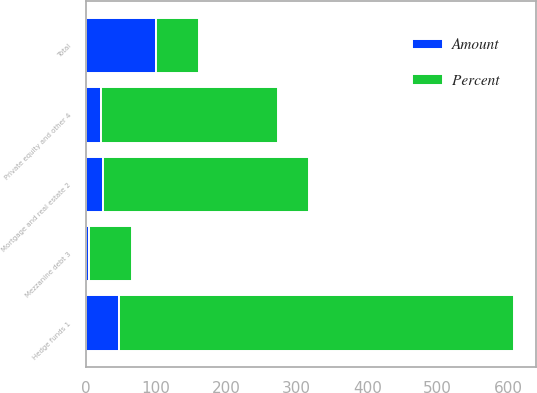<chart> <loc_0><loc_0><loc_500><loc_500><stacked_bar_chart><ecel><fcel>Hedge funds 1<fcel>Mortgage and real estate 2<fcel>Mezzanine debt 3<fcel>Private equity and other 4<fcel>Total<nl><fcel>Percent<fcel>561<fcel>292<fcel>61<fcel>252<fcel>61<nl><fcel>Amount<fcel>48.1<fcel>25.1<fcel>5.2<fcel>21.6<fcel>100<nl></chart> 